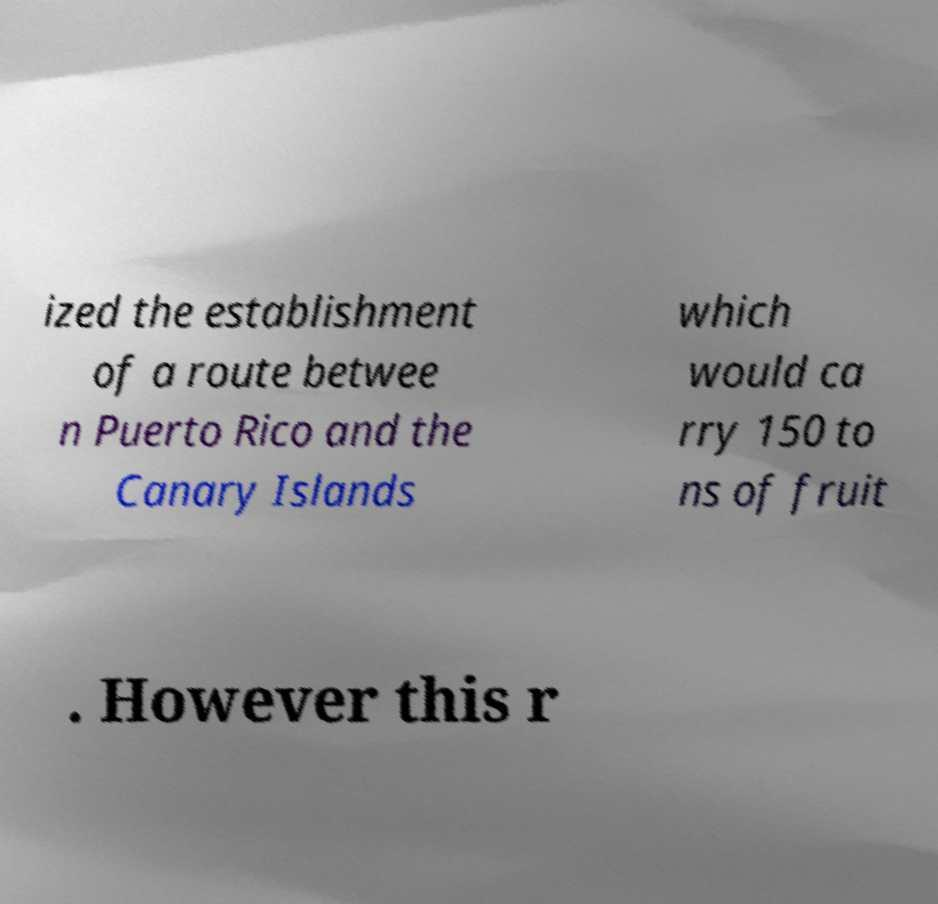For documentation purposes, I need the text within this image transcribed. Could you provide that? ized the establishment of a route betwee n Puerto Rico and the Canary Islands which would ca rry 150 to ns of fruit . However this r 